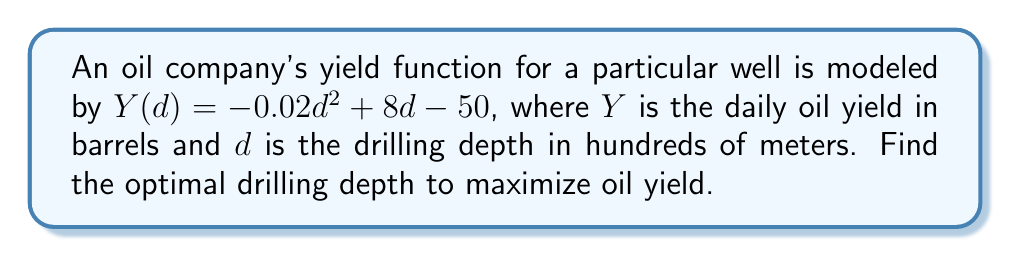Solve this math problem. To find the optimal drilling depth, we need to find the maximum of the yield function $Y(d)$. This can be done by following these steps:

1. Find the derivative of $Y(d)$ with respect to $d$:
   $$Y'(d) = -0.04d + 8$$

2. Set the derivative equal to zero to find the critical point:
   $$-0.04d + 8 = 0$$
   $$-0.04d = -8$$
   $$d = 200$$

3. Verify that this critical point is a maximum by checking the second derivative:
   $$Y''(d) = -0.04$$
   Since $Y''(d)$ is negative, the critical point is indeed a maximum.

4. Convert the result back to the original units:
   200 hundred meters = 20,000 meters

Therefore, the optimal drilling depth to maximize oil yield is 20,000 meters.
Answer: 20,000 meters 